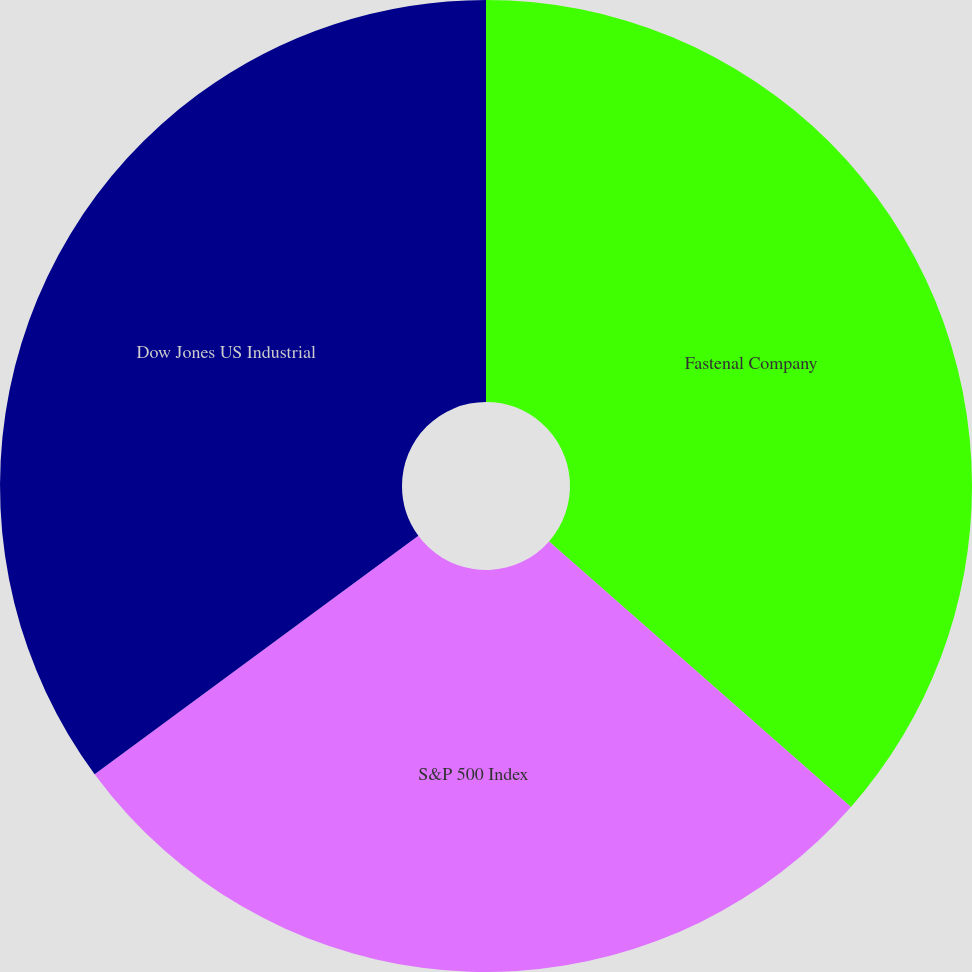Convert chart to OTSL. <chart><loc_0><loc_0><loc_500><loc_500><pie_chart><fcel>Fastenal Company<fcel>S&P 500 Index<fcel>Dow Jones US Industrial<nl><fcel>36.48%<fcel>28.42%<fcel>35.1%<nl></chart> 